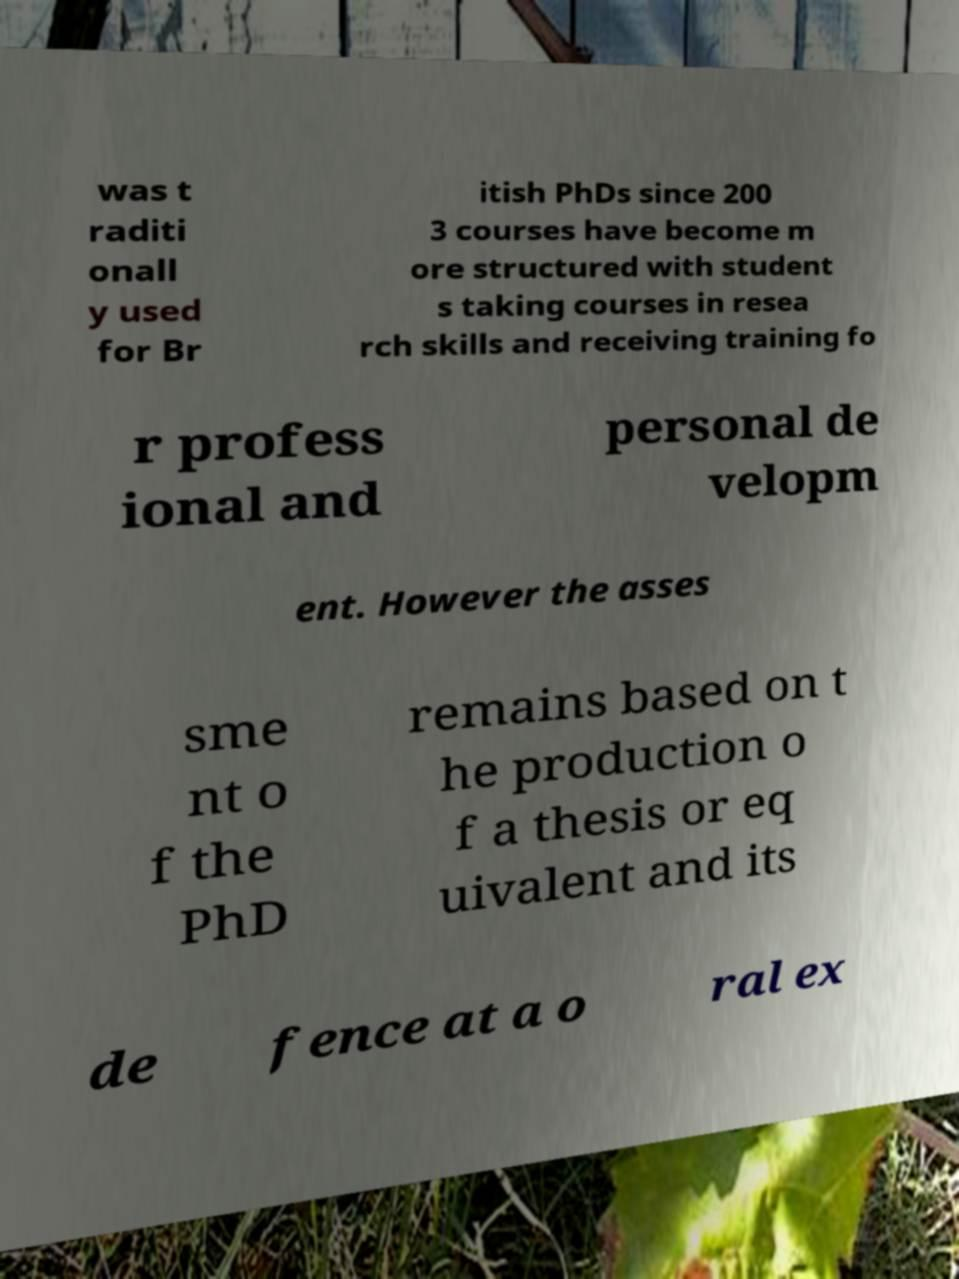Could you assist in decoding the text presented in this image and type it out clearly? was t raditi onall y used for Br itish PhDs since 200 3 courses have become m ore structured with student s taking courses in resea rch skills and receiving training fo r profess ional and personal de velopm ent. However the asses sme nt o f the PhD remains based on t he production o f a thesis or eq uivalent and its de fence at a o ral ex 